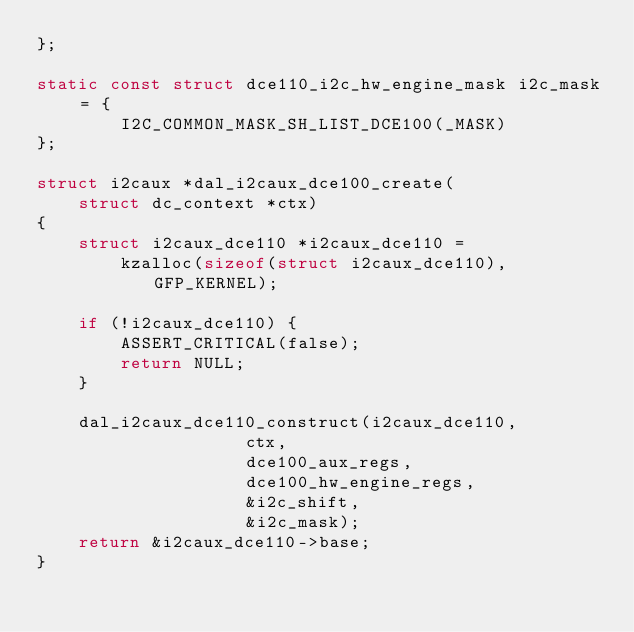<code> <loc_0><loc_0><loc_500><loc_500><_C_>};

static const struct dce110_i2c_hw_engine_mask i2c_mask = {
		I2C_COMMON_MASK_SH_LIST_DCE100(_MASK)
};

struct i2caux *dal_i2caux_dce100_create(
	struct dc_context *ctx)
{
	struct i2caux_dce110 *i2caux_dce110 =
		kzalloc(sizeof(struct i2caux_dce110), GFP_KERNEL);

	if (!i2caux_dce110) {
		ASSERT_CRITICAL(false);
		return NULL;
	}

	dal_i2caux_dce110_construct(i2caux_dce110,
				    ctx,
				    dce100_aux_regs,
				    dce100_hw_engine_regs,
				    &i2c_shift,
				    &i2c_mask);
	return &i2caux_dce110->base;
}
</code> 